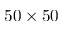Convert formula to latex. <formula><loc_0><loc_0><loc_500><loc_500>5 0 \times 5 0</formula> 